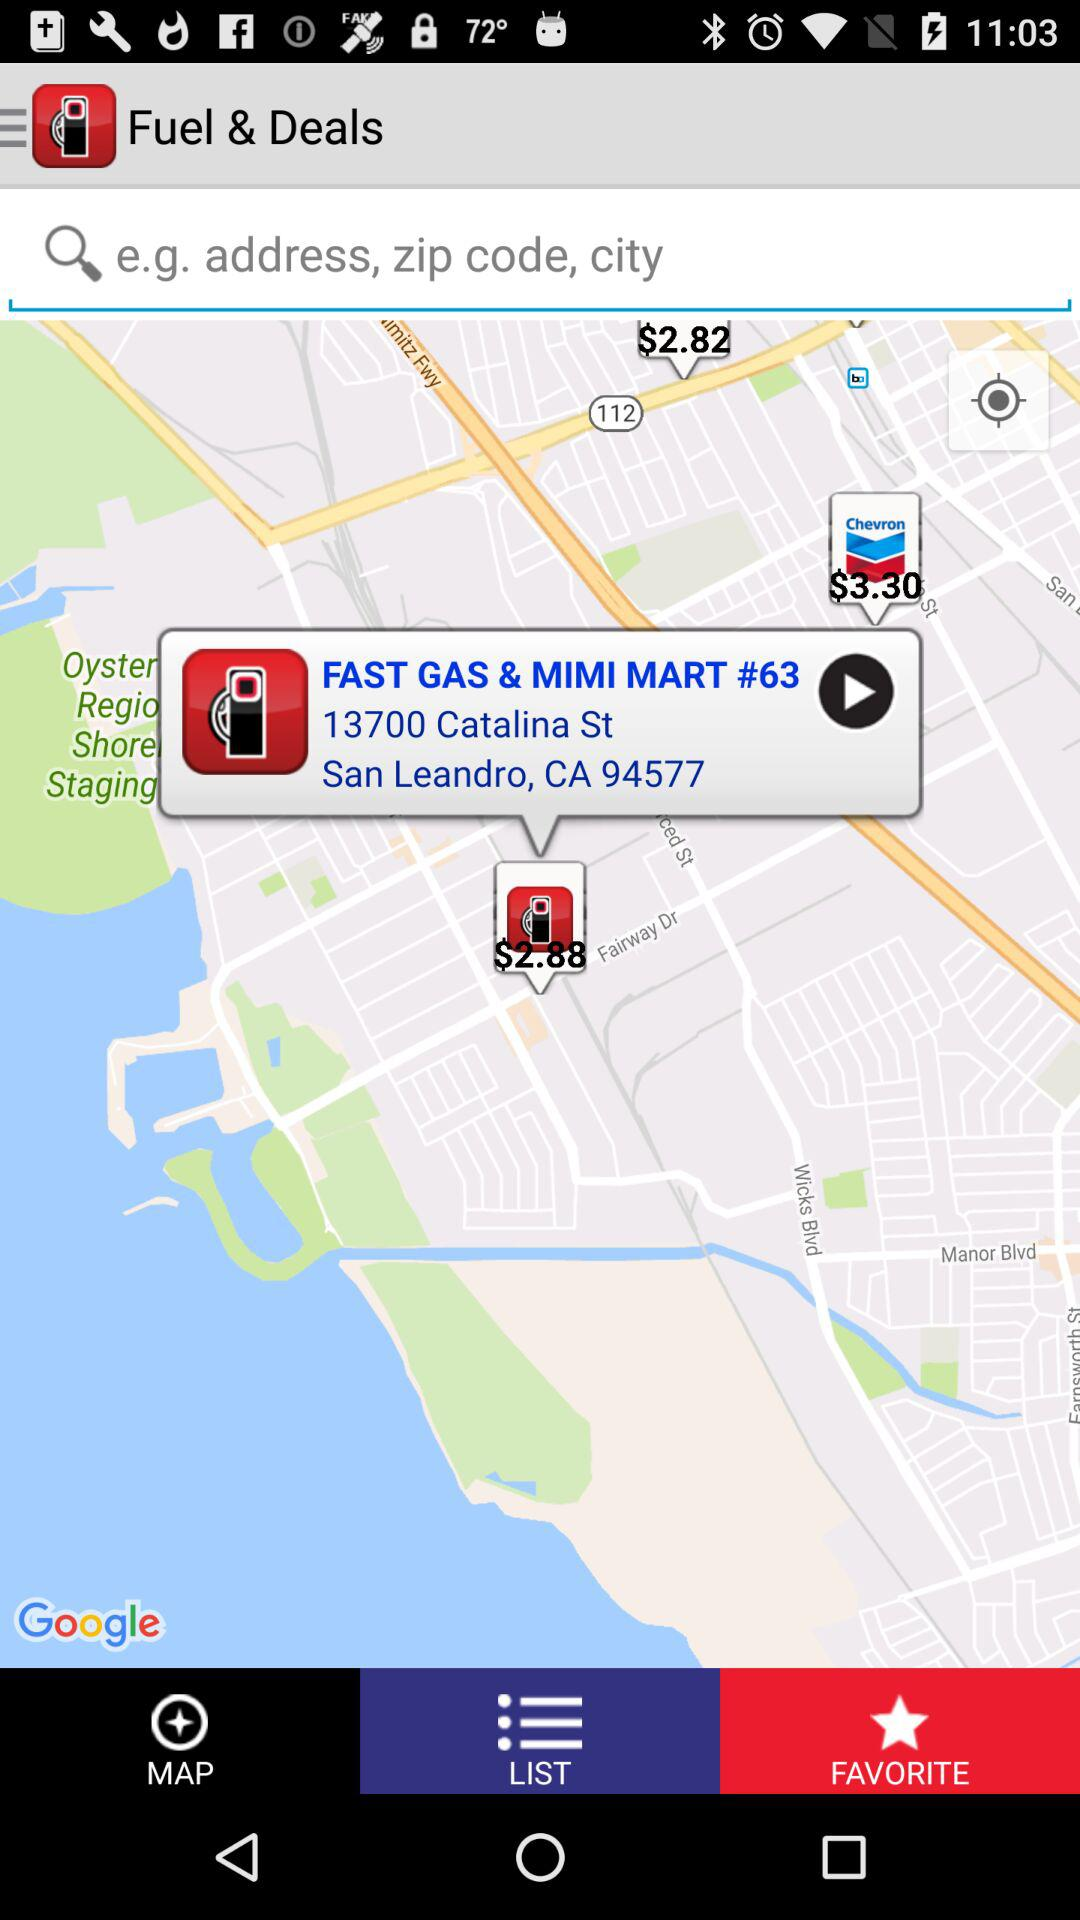How many locations are there on the map?
Answer the question using a single word or phrase. 1 